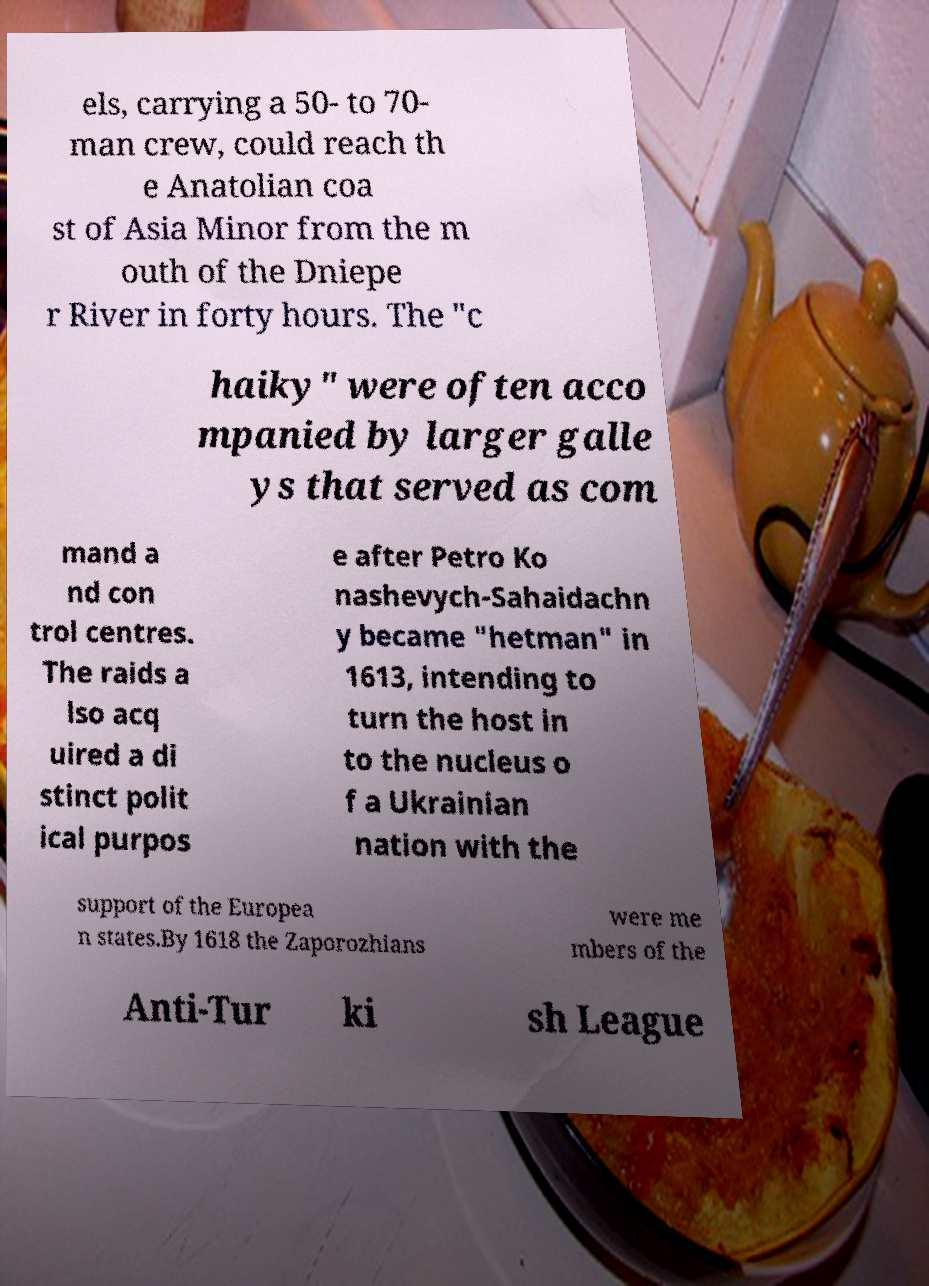Could you assist in decoding the text presented in this image and type it out clearly? els, carrying a 50- to 70- man crew, could reach th e Anatolian coa st of Asia Minor from the m outh of the Dniepe r River in forty hours. The "c haiky" were often acco mpanied by larger galle ys that served as com mand a nd con trol centres. The raids a lso acq uired a di stinct polit ical purpos e after Petro Ko nashevych-Sahaidachn y became "hetman" in 1613, intending to turn the host in to the nucleus o f a Ukrainian nation with the support of the Europea n states.By 1618 the Zaporozhians were me mbers of the Anti-Tur ki sh League 